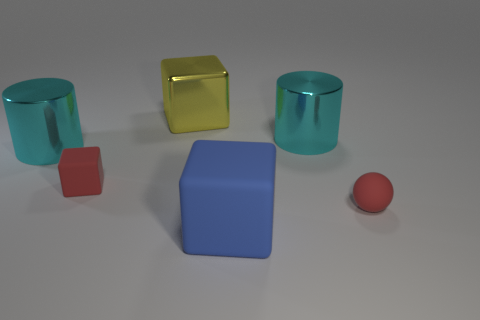There is another large object that is the same shape as the large blue thing; what is its material?
Provide a succinct answer. Metal. There is a tiny red thing that is to the left of the blue object; is it the same shape as the large cyan object right of the big rubber object?
Offer a very short reply. No. Are there fewer red matte objects behind the tiny red matte block than big rubber objects that are to the right of the large matte block?
Your answer should be very brief. No. What number of other things are there of the same shape as the big yellow metal object?
Give a very brief answer. 2. The big blue object that is made of the same material as the small red sphere is what shape?
Your response must be concise. Cube. What is the color of the thing that is both on the right side of the large matte cube and on the left side of the tiny sphere?
Provide a short and direct response. Cyan. Is the large thing that is right of the big blue block made of the same material as the yellow block?
Offer a terse response. Yes. Are there fewer tiny red rubber objects behind the red matte ball than red objects?
Your answer should be compact. Yes. Are there any small things that have the same material as the blue block?
Your answer should be very brief. Yes. Does the yellow metallic object have the same size as the cylinder on the right side of the blue rubber thing?
Your response must be concise. Yes. 